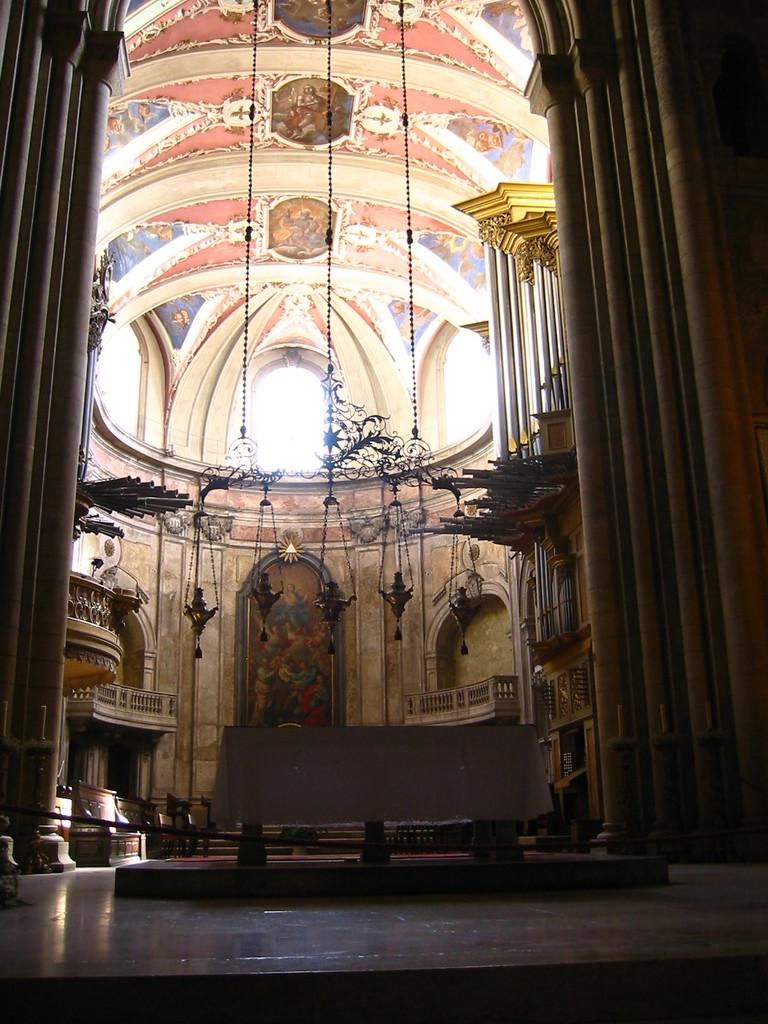What type of location is depicted in the image? The image shows an inner view of a building. What type of furniture is present in the image? There is a bench in the image. What type of decorations can be seen in the image? There are hangings visible in the image. What is depicted on the ceiling in the image? There is a painting on the ceiling in the image. What type of decision is being made by the chairs in the image? There are no chairs present in the image, and therefore no decisions can be made by them. 